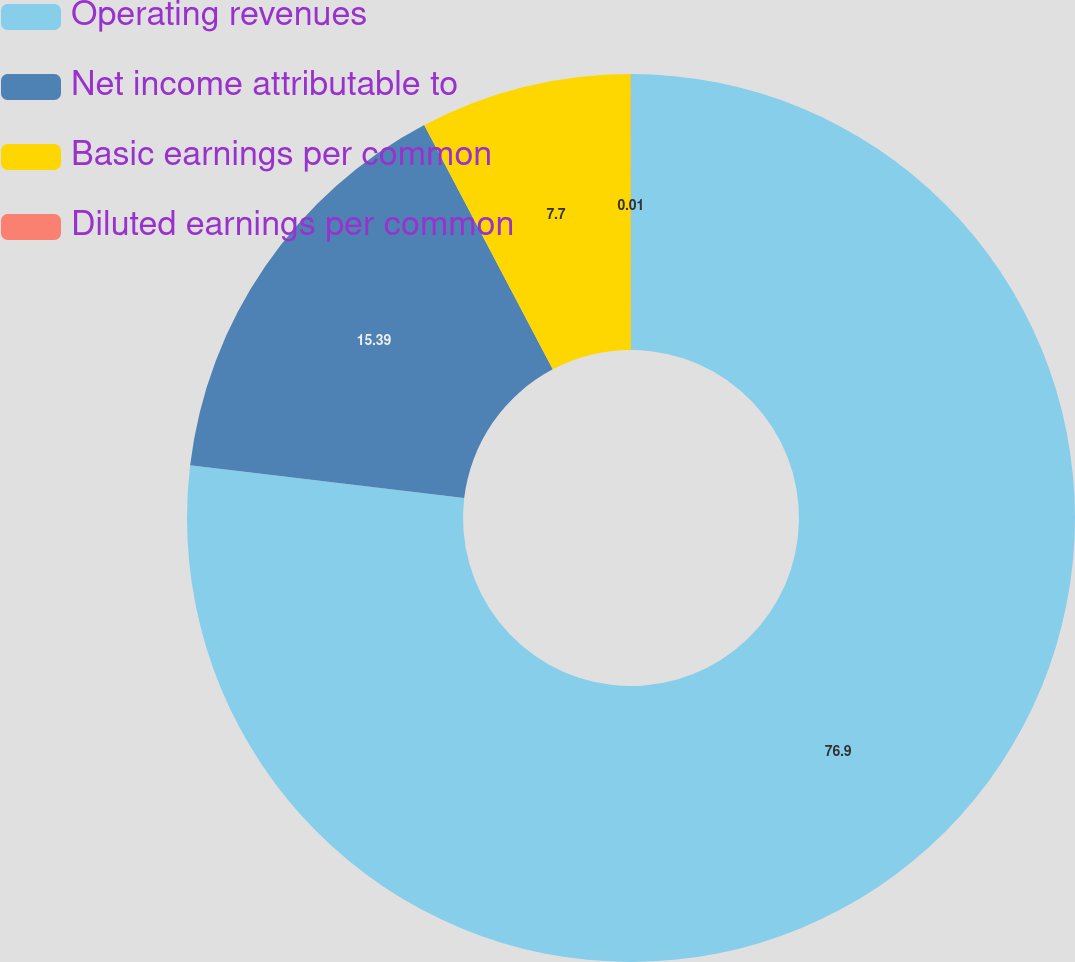Convert chart. <chart><loc_0><loc_0><loc_500><loc_500><pie_chart><fcel>Operating revenues<fcel>Net income attributable to<fcel>Basic earnings per common<fcel>Diluted earnings per common<nl><fcel>76.89%<fcel>15.39%<fcel>7.7%<fcel>0.01%<nl></chart> 